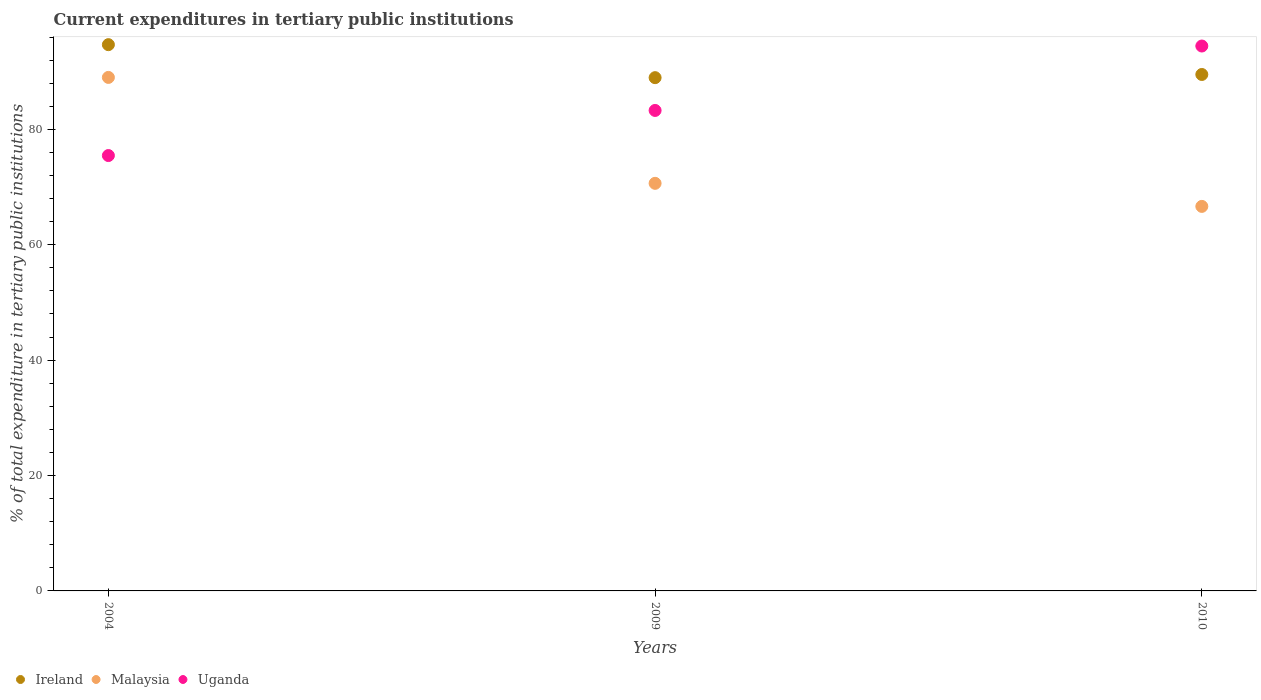How many different coloured dotlines are there?
Give a very brief answer. 3. Is the number of dotlines equal to the number of legend labels?
Offer a very short reply. Yes. What is the current expenditures in tertiary public institutions in Uganda in 2010?
Provide a succinct answer. 94.44. Across all years, what is the maximum current expenditures in tertiary public institutions in Ireland?
Give a very brief answer. 94.68. Across all years, what is the minimum current expenditures in tertiary public institutions in Ireland?
Your answer should be compact. 88.96. In which year was the current expenditures in tertiary public institutions in Ireland maximum?
Your answer should be very brief. 2004. What is the total current expenditures in tertiary public institutions in Malaysia in the graph?
Offer a terse response. 226.3. What is the difference between the current expenditures in tertiary public institutions in Uganda in 2004 and that in 2010?
Keep it short and to the point. -18.98. What is the difference between the current expenditures in tertiary public institutions in Uganda in 2004 and the current expenditures in tertiary public institutions in Malaysia in 2009?
Provide a succinct answer. 4.82. What is the average current expenditures in tertiary public institutions in Ireland per year?
Your answer should be very brief. 91.05. In the year 2009, what is the difference between the current expenditures in tertiary public institutions in Ireland and current expenditures in tertiary public institutions in Malaysia?
Provide a succinct answer. 18.32. What is the ratio of the current expenditures in tertiary public institutions in Malaysia in 2004 to that in 2009?
Provide a short and direct response. 1.26. Is the current expenditures in tertiary public institutions in Uganda in 2009 less than that in 2010?
Give a very brief answer. Yes. What is the difference between the highest and the second highest current expenditures in tertiary public institutions in Ireland?
Offer a very short reply. 5.17. What is the difference between the highest and the lowest current expenditures in tertiary public institutions in Malaysia?
Ensure brevity in your answer.  22.36. In how many years, is the current expenditures in tertiary public institutions in Uganda greater than the average current expenditures in tertiary public institutions in Uganda taken over all years?
Your answer should be very brief. 1. Is it the case that in every year, the sum of the current expenditures in tertiary public institutions in Uganda and current expenditures in tertiary public institutions in Malaysia  is greater than the current expenditures in tertiary public institutions in Ireland?
Your answer should be compact. Yes. Does the current expenditures in tertiary public institutions in Ireland monotonically increase over the years?
Your response must be concise. No. Is the current expenditures in tertiary public institutions in Malaysia strictly less than the current expenditures in tertiary public institutions in Ireland over the years?
Give a very brief answer. Yes. How many dotlines are there?
Provide a short and direct response. 3. Are the values on the major ticks of Y-axis written in scientific E-notation?
Give a very brief answer. No. Where does the legend appear in the graph?
Give a very brief answer. Bottom left. What is the title of the graph?
Ensure brevity in your answer.  Current expenditures in tertiary public institutions. Does "South Africa" appear as one of the legend labels in the graph?
Provide a short and direct response. No. What is the label or title of the X-axis?
Provide a succinct answer. Years. What is the label or title of the Y-axis?
Make the answer very short. % of total expenditure in tertiary public institutions. What is the % of total expenditure in tertiary public institutions of Ireland in 2004?
Make the answer very short. 94.68. What is the % of total expenditure in tertiary public institutions of Malaysia in 2004?
Offer a very short reply. 89. What is the % of total expenditure in tertiary public institutions of Uganda in 2004?
Make the answer very short. 75.46. What is the % of total expenditure in tertiary public institutions in Ireland in 2009?
Provide a succinct answer. 88.96. What is the % of total expenditure in tertiary public institutions of Malaysia in 2009?
Your answer should be very brief. 70.64. What is the % of total expenditure in tertiary public institutions of Uganda in 2009?
Your response must be concise. 83.28. What is the % of total expenditure in tertiary public institutions in Ireland in 2010?
Your answer should be compact. 89.51. What is the % of total expenditure in tertiary public institutions of Malaysia in 2010?
Your answer should be compact. 66.65. What is the % of total expenditure in tertiary public institutions of Uganda in 2010?
Your answer should be compact. 94.44. Across all years, what is the maximum % of total expenditure in tertiary public institutions in Ireland?
Give a very brief answer. 94.68. Across all years, what is the maximum % of total expenditure in tertiary public institutions of Malaysia?
Make the answer very short. 89. Across all years, what is the maximum % of total expenditure in tertiary public institutions in Uganda?
Offer a very short reply. 94.44. Across all years, what is the minimum % of total expenditure in tertiary public institutions in Ireland?
Provide a succinct answer. 88.96. Across all years, what is the minimum % of total expenditure in tertiary public institutions of Malaysia?
Give a very brief answer. 66.65. Across all years, what is the minimum % of total expenditure in tertiary public institutions in Uganda?
Ensure brevity in your answer.  75.46. What is the total % of total expenditure in tertiary public institutions of Ireland in the graph?
Give a very brief answer. 273.15. What is the total % of total expenditure in tertiary public institutions of Malaysia in the graph?
Keep it short and to the point. 226.3. What is the total % of total expenditure in tertiary public institutions of Uganda in the graph?
Provide a short and direct response. 253.18. What is the difference between the % of total expenditure in tertiary public institutions in Ireland in 2004 and that in 2009?
Make the answer very short. 5.72. What is the difference between the % of total expenditure in tertiary public institutions in Malaysia in 2004 and that in 2009?
Your answer should be compact. 18.36. What is the difference between the % of total expenditure in tertiary public institutions in Uganda in 2004 and that in 2009?
Give a very brief answer. -7.82. What is the difference between the % of total expenditure in tertiary public institutions in Ireland in 2004 and that in 2010?
Your answer should be very brief. 5.17. What is the difference between the % of total expenditure in tertiary public institutions of Malaysia in 2004 and that in 2010?
Your answer should be very brief. 22.36. What is the difference between the % of total expenditure in tertiary public institutions of Uganda in 2004 and that in 2010?
Make the answer very short. -18.98. What is the difference between the % of total expenditure in tertiary public institutions in Ireland in 2009 and that in 2010?
Make the answer very short. -0.55. What is the difference between the % of total expenditure in tertiary public institutions in Malaysia in 2009 and that in 2010?
Your answer should be very brief. 4. What is the difference between the % of total expenditure in tertiary public institutions in Uganda in 2009 and that in 2010?
Your answer should be compact. -11.17. What is the difference between the % of total expenditure in tertiary public institutions in Ireland in 2004 and the % of total expenditure in tertiary public institutions in Malaysia in 2009?
Your answer should be very brief. 24.04. What is the difference between the % of total expenditure in tertiary public institutions of Ireland in 2004 and the % of total expenditure in tertiary public institutions of Uganda in 2009?
Your answer should be compact. 11.4. What is the difference between the % of total expenditure in tertiary public institutions in Malaysia in 2004 and the % of total expenditure in tertiary public institutions in Uganda in 2009?
Your answer should be very brief. 5.73. What is the difference between the % of total expenditure in tertiary public institutions of Ireland in 2004 and the % of total expenditure in tertiary public institutions of Malaysia in 2010?
Give a very brief answer. 28.03. What is the difference between the % of total expenditure in tertiary public institutions of Ireland in 2004 and the % of total expenditure in tertiary public institutions of Uganda in 2010?
Make the answer very short. 0.24. What is the difference between the % of total expenditure in tertiary public institutions of Malaysia in 2004 and the % of total expenditure in tertiary public institutions of Uganda in 2010?
Provide a succinct answer. -5.44. What is the difference between the % of total expenditure in tertiary public institutions in Ireland in 2009 and the % of total expenditure in tertiary public institutions in Malaysia in 2010?
Give a very brief answer. 22.31. What is the difference between the % of total expenditure in tertiary public institutions in Ireland in 2009 and the % of total expenditure in tertiary public institutions in Uganda in 2010?
Provide a succinct answer. -5.48. What is the difference between the % of total expenditure in tertiary public institutions of Malaysia in 2009 and the % of total expenditure in tertiary public institutions of Uganda in 2010?
Keep it short and to the point. -23.8. What is the average % of total expenditure in tertiary public institutions in Ireland per year?
Give a very brief answer. 91.05. What is the average % of total expenditure in tertiary public institutions in Malaysia per year?
Give a very brief answer. 75.43. What is the average % of total expenditure in tertiary public institutions in Uganda per year?
Your response must be concise. 84.39. In the year 2004, what is the difference between the % of total expenditure in tertiary public institutions of Ireland and % of total expenditure in tertiary public institutions of Malaysia?
Your answer should be compact. 5.68. In the year 2004, what is the difference between the % of total expenditure in tertiary public institutions in Ireland and % of total expenditure in tertiary public institutions in Uganda?
Your response must be concise. 19.22. In the year 2004, what is the difference between the % of total expenditure in tertiary public institutions in Malaysia and % of total expenditure in tertiary public institutions in Uganda?
Make the answer very short. 13.54. In the year 2009, what is the difference between the % of total expenditure in tertiary public institutions in Ireland and % of total expenditure in tertiary public institutions in Malaysia?
Give a very brief answer. 18.32. In the year 2009, what is the difference between the % of total expenditure in tertiary public institutions of Ireland and % of total expenditure in tertiary public institutions of Uganda?
Ensure brevity in your answer.  5.68. In the year 2009, what is the difference between the % of total expenditure in tertiary public institutions in Malaysia and % of total expenditure in tertiary public institutions in Uganda?
Keep it short and to the point. -12.63. In the year 2010, what is the difference between the % of total expenditure in tertiary public institutions of Ireland and % of total expenditure in tertiary public institutions of Malaysia?
Provide a succinct answer. 22.86. In the year 2010, what is the difference between the % of total expenditure in tertiary public institutions of Ireland and % of total expenditure in tertiary public institutions of Uganda?
Keep it short and to the point. -4.93. In the year 2010, what is the difference between the % of total expenditure in tertiary public institutions of Malaysia and % of total expenditure in tertiary public institutions of Uganda?
Offer a very short reply. -27.8. What is the ratio of the % of total expenditure in tertiary public institutions of Ireland in 2004 to that in 2009?
Provide a succinct answer. 1.06. What is the ratio of the % of total expenditure in tertiary public institutions of Malaysia in 2004 to that in 2009?
Keep it short and to the point. 1.26. What is the ratio of the % of total expenditure in tertiary public institutions of Uganda in 2004 to that in 2009?
Offer a terse response. 0.91. What is the ratio of the % of total expenditure in tertiary public institutions of Ireland in 2004 to that in 2010?
Keep it short and to the point. 1.06. What is the ratio of the % of total expenditure in tertiary public institutions of Malaysia in 2004 to that in 2010?
Offer a terse response. 1.34. What is the ratio of the % of total expenditure in tertiary public institutions in Uganda in 2004 to that in 2010?
Your response must be concise. 0.8. What is the ratio of the % of total expenditure in tertiary public institutions in Malaysia in 2009 to that in 2010?
Keep it short and to the point. 1.06. What is the ratio of the % of total expenditure in tertiary public institutions of Uganda in 2009 to that in 2010?
Make the answer very short. 0.88. What is the difference between the highest and the second highest % of total expenditure in tertiary public institutions of Ireland?
Make the answer very short. 5.17. What is the difference between the highest and the second highest % of total expenditure in tertiary public institutions of Malaysia?
Ensure brevity in your answer.  18.36. What is the difference between the highest and the second highest % of total expenditure in tertiary public institutions of Uganda?
Your response must be concise. 11.17. What is the difference between the highest and the lowest % of total expenditure in tertiary public institutions of Ireland?
Your answer should be compact. 5.72. What is the difference between the highest and the lowest % of total expenditure in tertiary public institutions of Malaysia?
Keep it short and to the point. 22.36. What is the difference between the highest and the lowest % of total expenditure in tertiary public institutions of Uganda?
Provide a succinct answer. 18.98. 